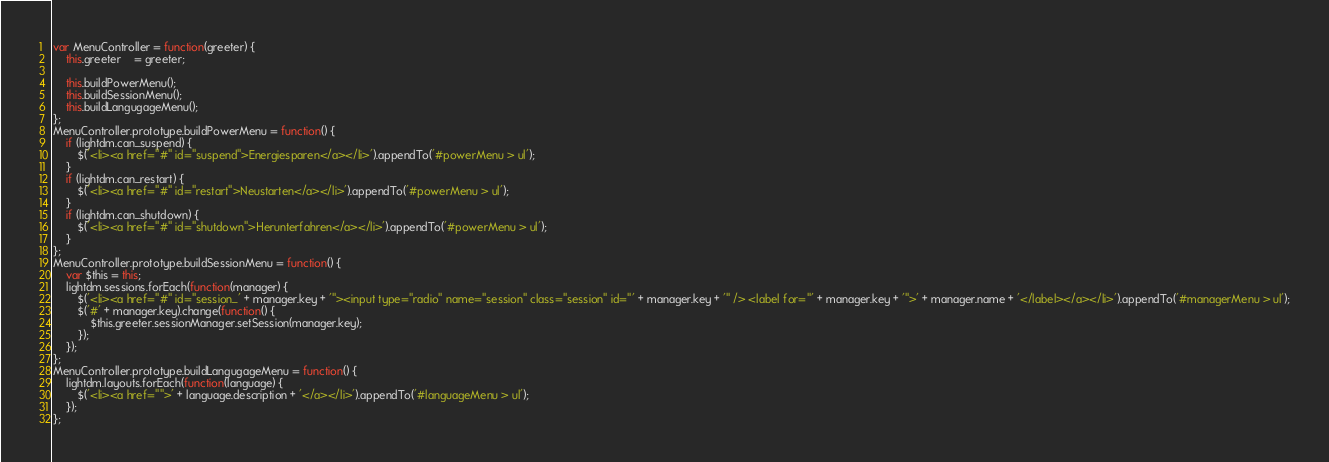Convert code to text. <code><loc_0><loc_0><loc_500><loc_500><_JavaScript_>var MenuController = function(greeter) {
	this.greeter	= greeter;

	this.buildPowerMenu();
	this.buildSessionMenu();
	this.buildLangugageMenu();
};
MenuController.prototype.buildPowerMenu = function() {
	if (lightdm.can_suspend) {
		$('<li><a href="#" id="suspend">Energiesparen</a></li>').appendTo('#powerMenu > ul');
	}
	if (lightdm.can_restart) {
		$('<li><a href="#" id="restart">Neustarten</a></li>').appendTo('#powerMenu > ul');
	}
	if (lightdm.can_shutdown) {
		$('<li><a href="#" id="shutdown">Herunterfahren</a></li>').appendTo('#powerMenu > ul');
	}
};
MenuController.prototype.buildSessionMenu = function() {
	var $this = this;
	lightdm.sessions.forEach(function(manager) {
		$('<li><a href="#" id="session_' + manager.key + '"><input type="radio" name="session" class="session" id="' + manager.key + '" /> <label for="' + manager.key + '">' + manager.name + '</label></a></li>').appendTo('#managerMenu > ul');
		$('#' + manager.key).change(function() {
			$this.greeter.sessionManager.setSession(manager.key);
		});
	});
};
MenuController.prototype.buildLangugageMenu = function() {
	lightdm.layouts.forEach(function(language) {
		$('<li><a href="">' + language.description + '</a></li>').appendTo('#languageMenu > ul');
	});
};</code> 